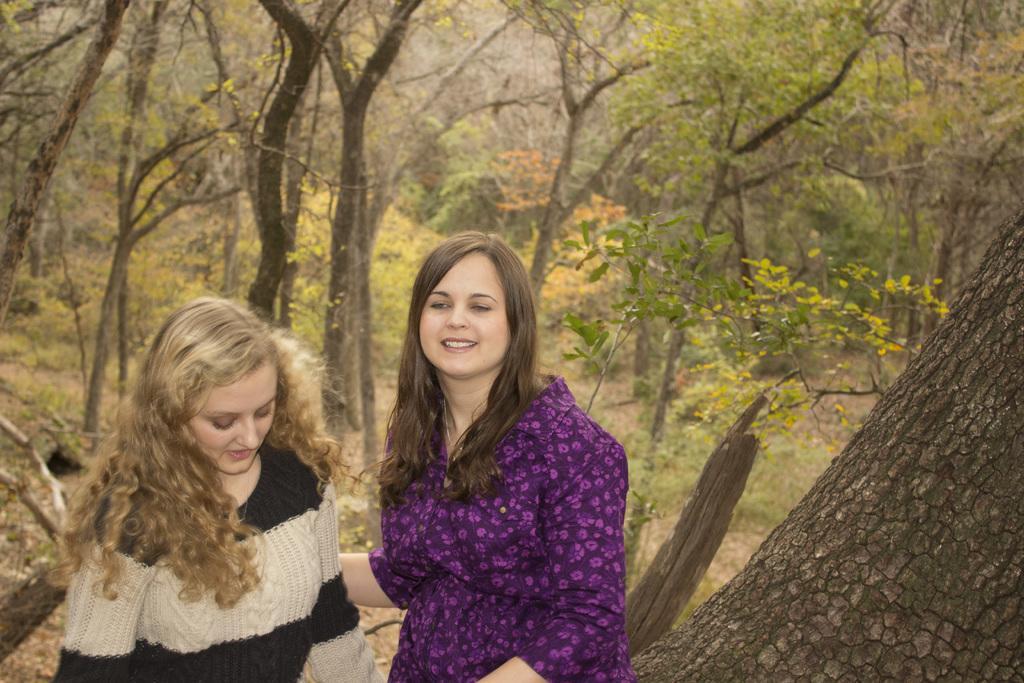Can you describe this image briefly? In this image I can see on the left side a woman is looking down. She wore black and white sweater, in the middle a beautiful woman is smiling. She wore purple color shirt, behind her there are trees with green leaves. 